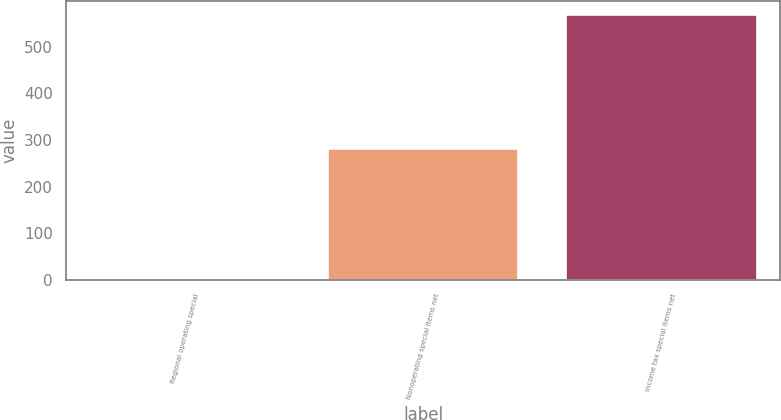Convert chart to OTSL. <chart><loc_0><loc_0><loc_500><loc_500><bar_chart><fcel>Regional operating special<fcel>Nonoperating special items net<fcel>Income tax special items net<nl><fcel>1<fcel>280<fcel>569<nl></chart> 